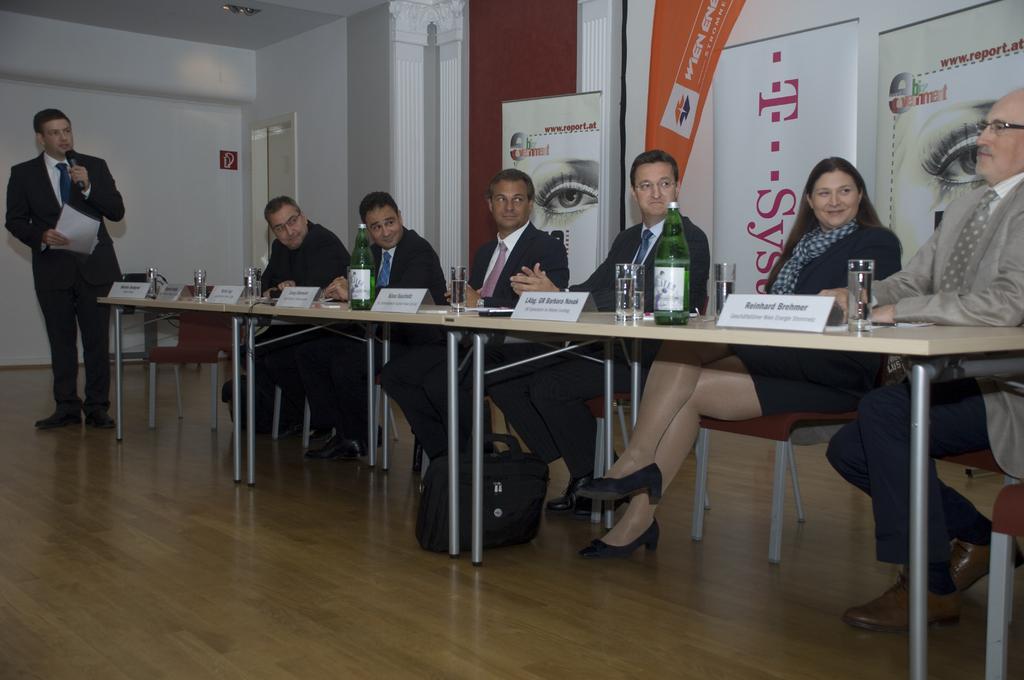How would you summarize this image in a sentence or two? In this image there are group of persons who are sitting on the chairs at the left side of the image there is a person standing and holding paper and microphone in his hands and there are some bottles,glasses,name boards on top of the table and at the background of the image there is a wall. 